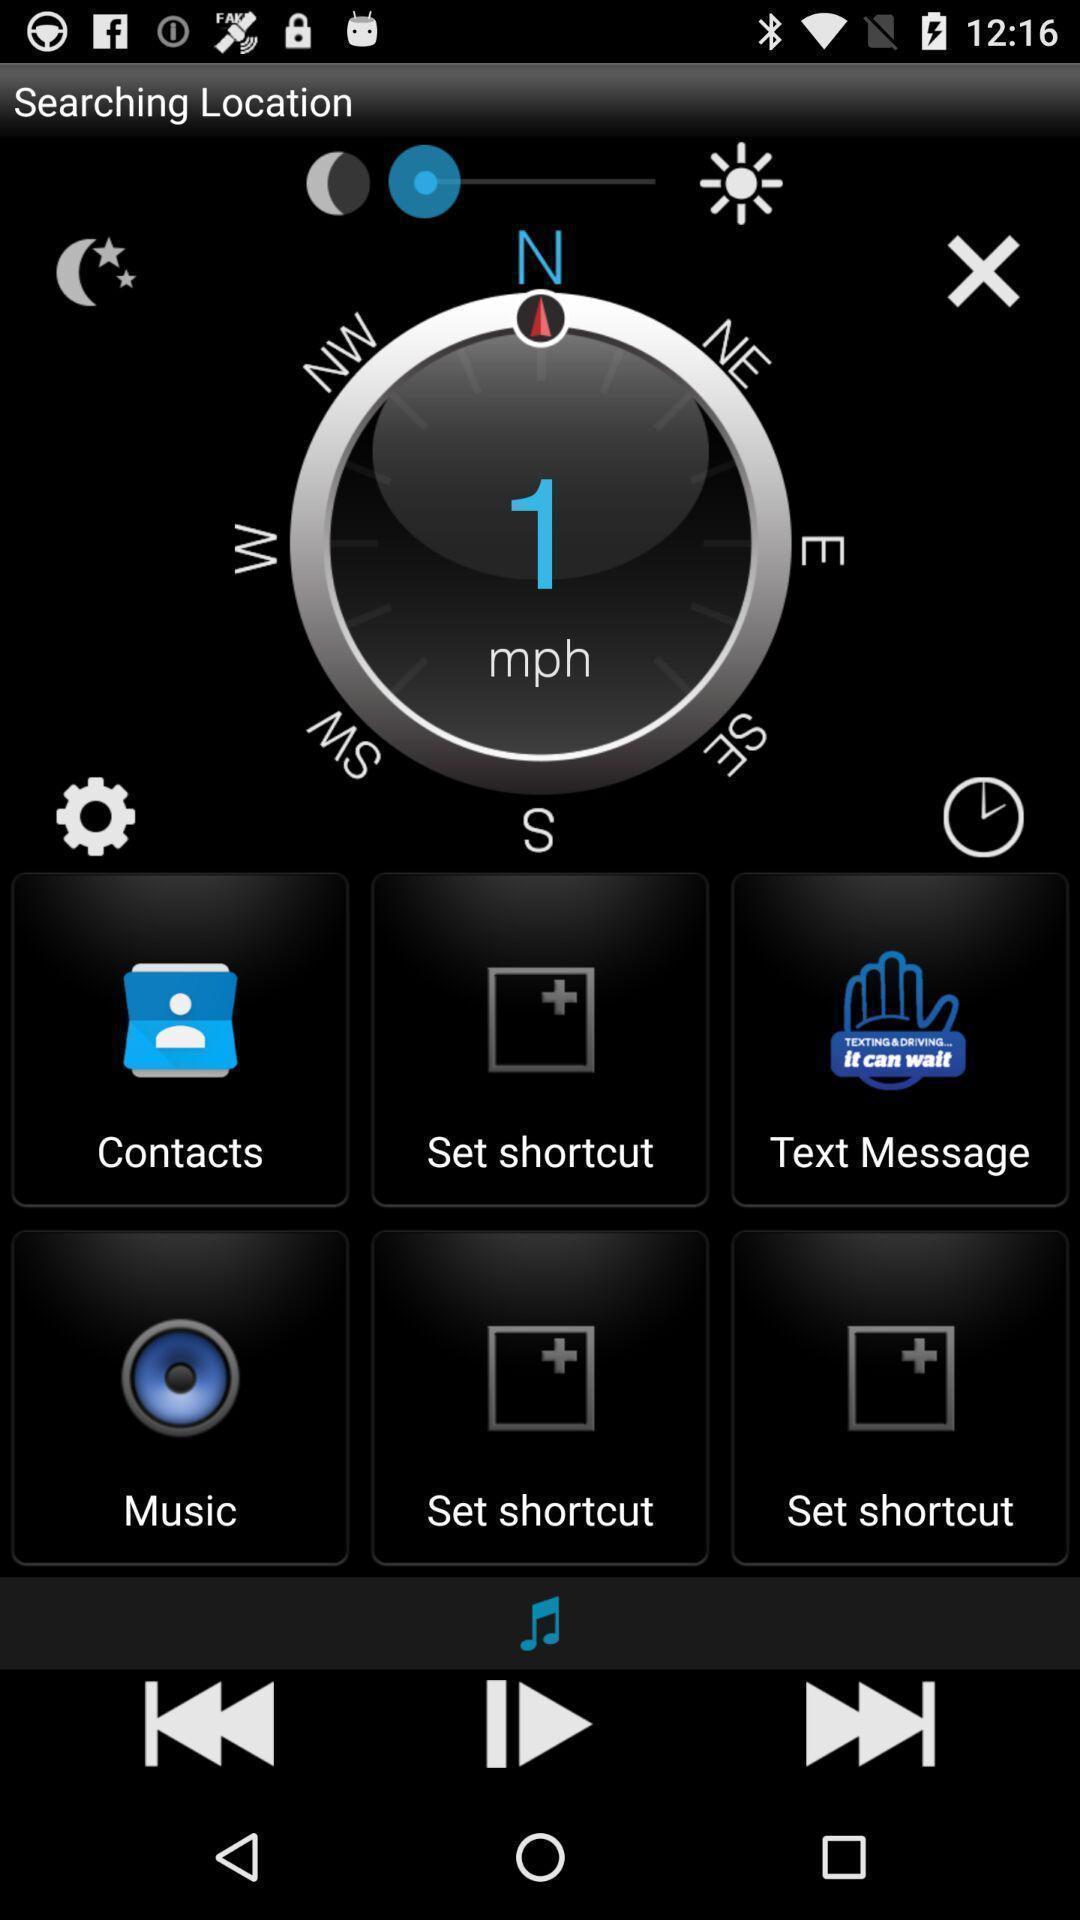Describe the key features of this screenshot. Page displaying the speed and various options. 